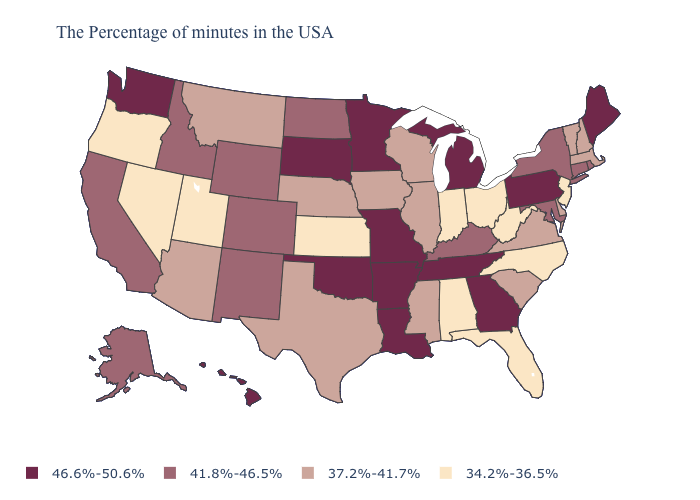Is the legend a continuous bar?
Short answer required. No. Among the states that border Iowa , does Illinois have the lowest value?
Write a very short answer. Yes. Name the states that have a value in the range 34.2%-36.5%?
Concise answer only. New Jersey, North Carolina, West Virginia, Ohio, Florida, Indiana, Alabama, Kansas, Utah, Nevada, Oregon. Which states have the highest value in the USA?
Keep it brief. Maine, Pennsylvania, Georgia, Michigan, Tennessee, Louisiana, Missouri, Arkansas, Minnesota, Oklahoma, South Dakota, Washington, Hawaii. What is the highest value in the USA?
Be succinct. 46.6%-50.6%. What is the lowest value in the South?
Concise answer only. 34.2%-36.5%. What is the highest value in states that border Georgia?
Short answer required. 46.6%-50.6%. Name the states that have a value in the range 37.2%-41.7%?
Answer briefly. Massachusetts, New Hampshire, Vermont, Delaware, Virginia, South Carolina, Wisconsin, Illinois, Mississippi, Iowa, Nebraska, Texas, Montana, Arizona. How many symbols are there in the legend?
Answer briefly. 4. Does Louisiana have the highest value in the USA?
Give a very brief answer. Yes. Among the states that border Connecticut , which have the lowest value?
Concise answer only. Massachusetts. What is the value of Kansas?
Give a very brief answer. 34.2%-36.5%. Which states have the highest value in the USA?
Short answer required. Maine, Pennsylvania, Georgia, Michigan, Tennessee, Louisiana, Missouri, Arkansas, Minnesota, Oklahoma, South Dakota, Washington, Hawaii. What is the value of Montana?
Keep it brief. 37.2%-41.7%. 